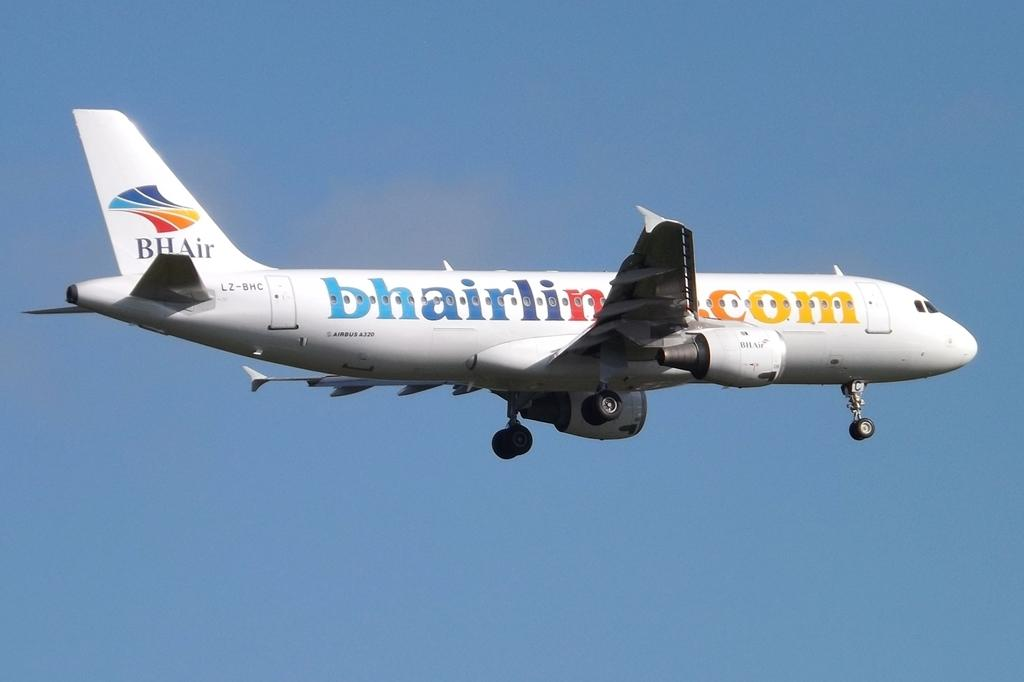Where was the image taken? The image was taken outdoors. What can be seen in the background of the image? There is a sky visible in the background of the image. What is happening in the sky in the middle of the image? An airplane is flying in the sky in the middle of the image. What type of bubble is being blown by the airplane in the image? There is no bubble being blown by the airplane in the image; it is simply flying in the sky. 